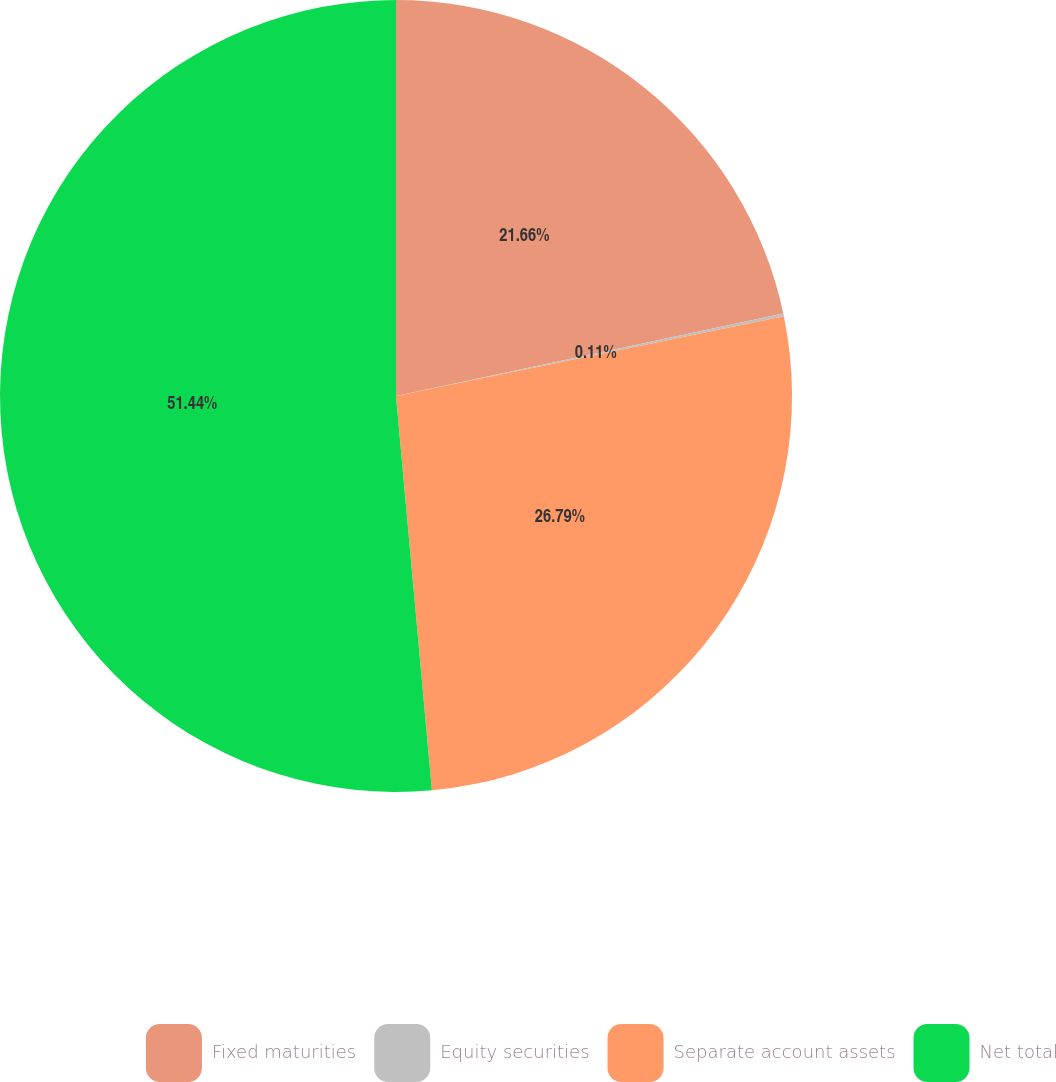<chart> <loc_0><loc_0><loc_500><loc_500><pie_chart><fcel>Fixed maturities<fcel>Equity securities<fcel>Separate account assets<fcel>Net total<nl><fcel>21.66%<fcel>0.11%<fcel>26.79%<fcel>51.45%<nl></chart> 